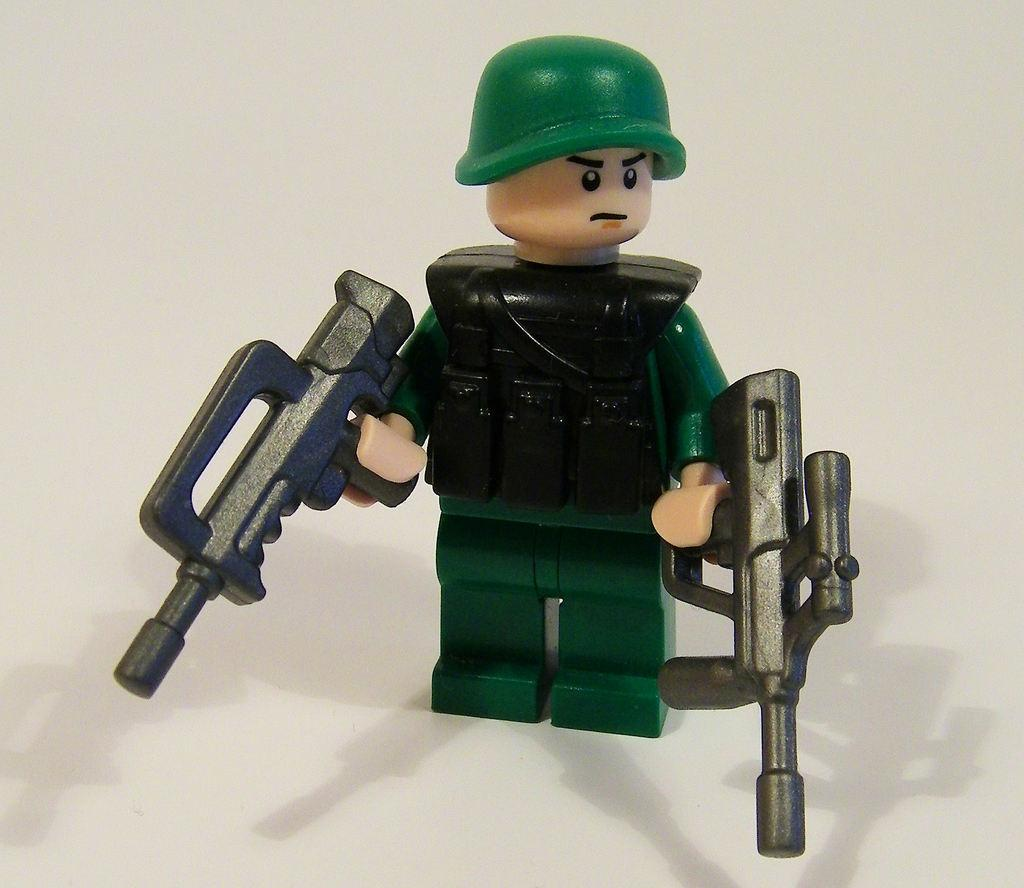What is the main subject of the picture? The main subject of the picture is a toy. What is the toy holding? The toy is holding guns and a helmet. What is the color of the surface the toy is on? The toy is on a white surface. Can you see a snail crawling on the toy in the image? There is no snail present in the image. What type of agreement is being made between the toy and the helmet in the image? There is no agreement being made in the image; it is a still image of a toy holding a helmet and guns. 